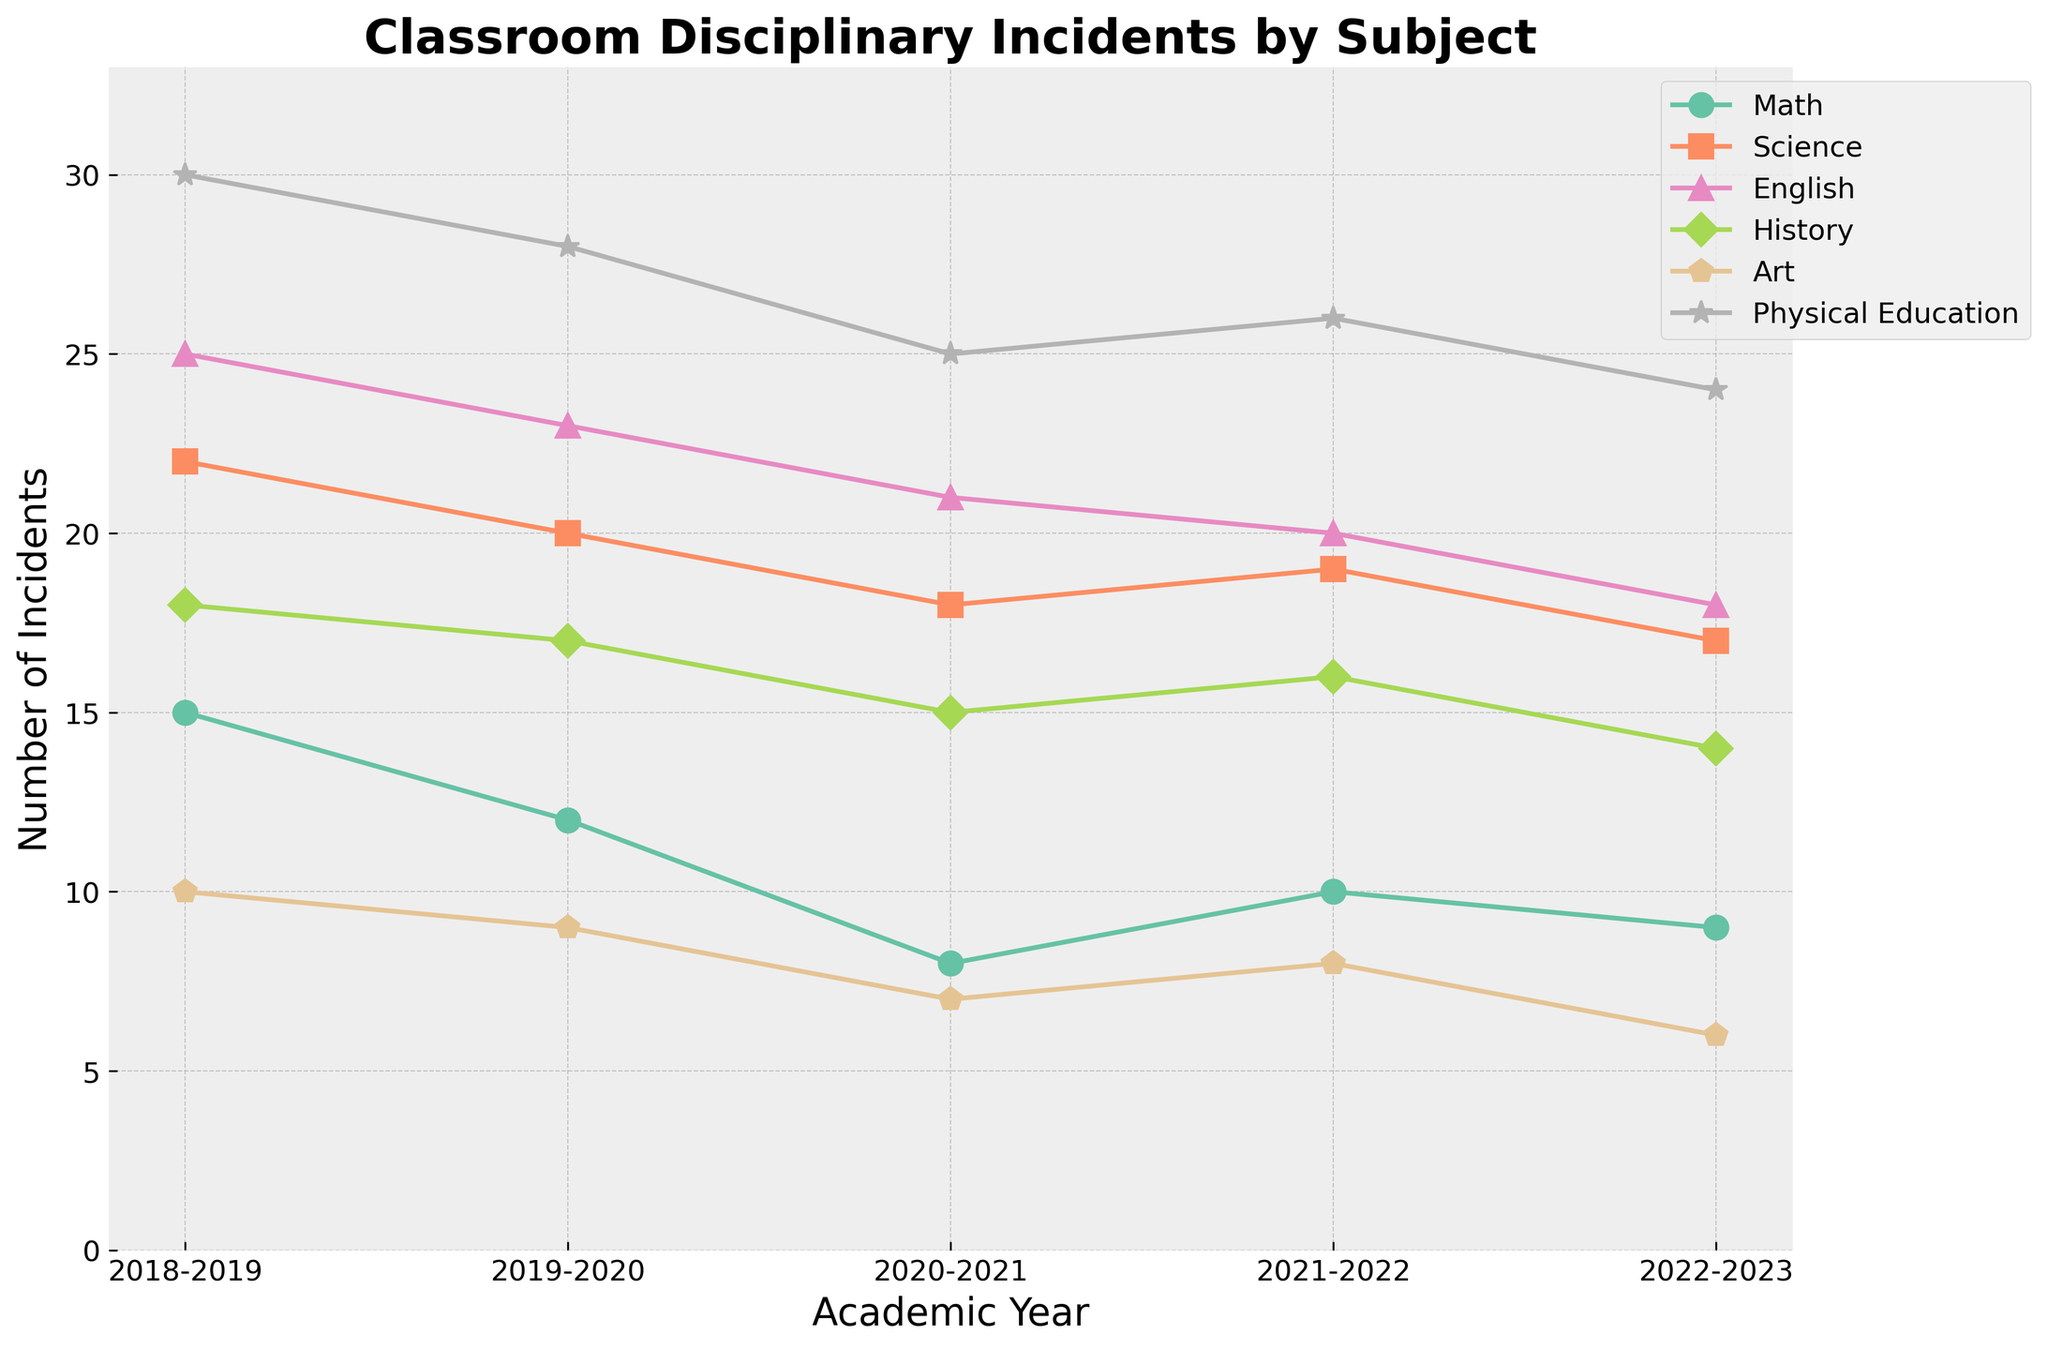What subject had the highest number of disciplinary incidents in the 2022-2023 academic year? We look at the endpoints of each line for the 2022-2023 academic year. Physical Education has the highest position on the y-axis, indicating it had the highest number of incidents.
Answer: Physical Education Which subject saw a decrease in the number of disciplinary incidents from 2019-2020 to 2020-2021? By examining the slope of the lines between 2019-2020 and 2020-2021, Art shows a decline, indicated by a downward slope.
Answer: Art What is the difference in the number of disciplinary incidents between Math and Science in the 2021-2022 academic year? Locate the data points for Math and Science in the 2021-2022 academic year. Math had 10 incidents, while Science had 19. The difference is 19 - 10.
Answer: 9 Which subject experienced the smallest change in the number of disciplinary incidents over the five academic years? We need to evaluate the range (max-min) of the lines. Math ranges from 8 to 15 (a change of 7), which is the smallest change compared to other subjects.
Answer: Math On average, how many disciplinary incidents were reported in English classes per year? Calculate the average number of incidents by summing the values for English: (25 + 23 + 21 + 20 + 18) = 107, then divide by the number of years (5).
Answer: 21.4 Between 2018-2019 and 2022-2023, which subject had the largest absolute decrease in the number of disciplinary incidents? Find the differences for each subject from 2018-2019 to 2022-2023. Physical Education has the largest decrease: 30 - 24 = 6
Answer: Physical Education In the 2019-2020 academic year, which subjects had fewer disciplinary incidents than Physical Education? In 2019-2020, Physical Education had 28 incidents. Subjects with fewer incidents are Math (12), Art (9), and History (17).
Answer: Math, Art, History Compare the total number of disciplinary incidents in Science and History over the five academic years. Which subject had fewer incidents overall? Sum the incidents for both subjects: Science = 22+20+18+19+17 = 96, History = 18+17+15+16+14 = 80. History had fewer incidents.
Answer: History In which academic year did the number of disciplinary incidents in Art classes reach its lowest value? The line representing Art reaches its lowest point in the 2022-2023 academic year with 6 incidents.
Answer: 2022-2023 